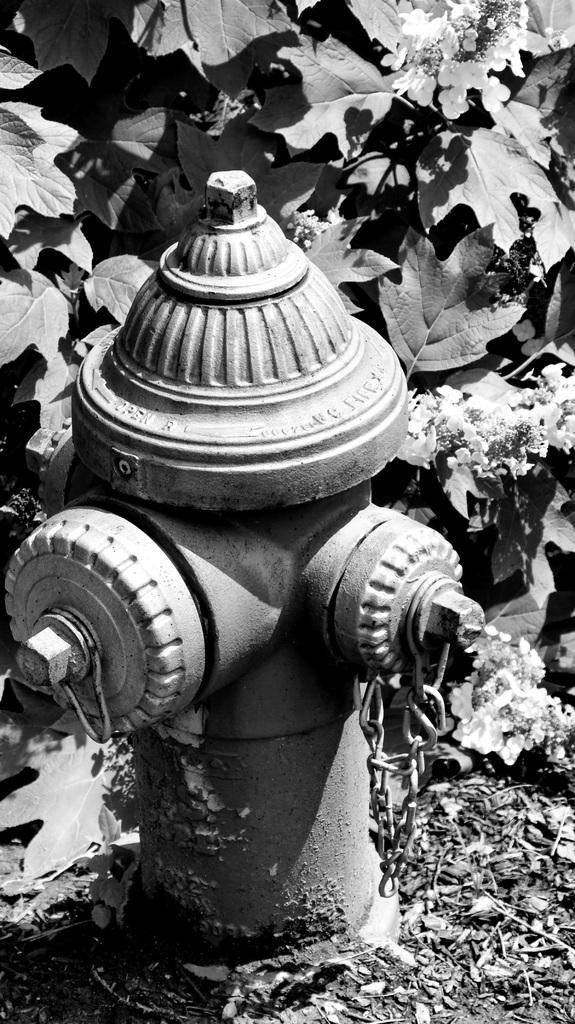What is the color scheme of the image? The image is black and white. What is the main object in the center of the image? There is a standpipe with a chain in the center of the image. What can be seen in the background of the image? Leaves and flowers are visible in the background of the image. What is the weather like in the image? The provided facts do not mention any information about the weather, so it cannot be determined from the image. 